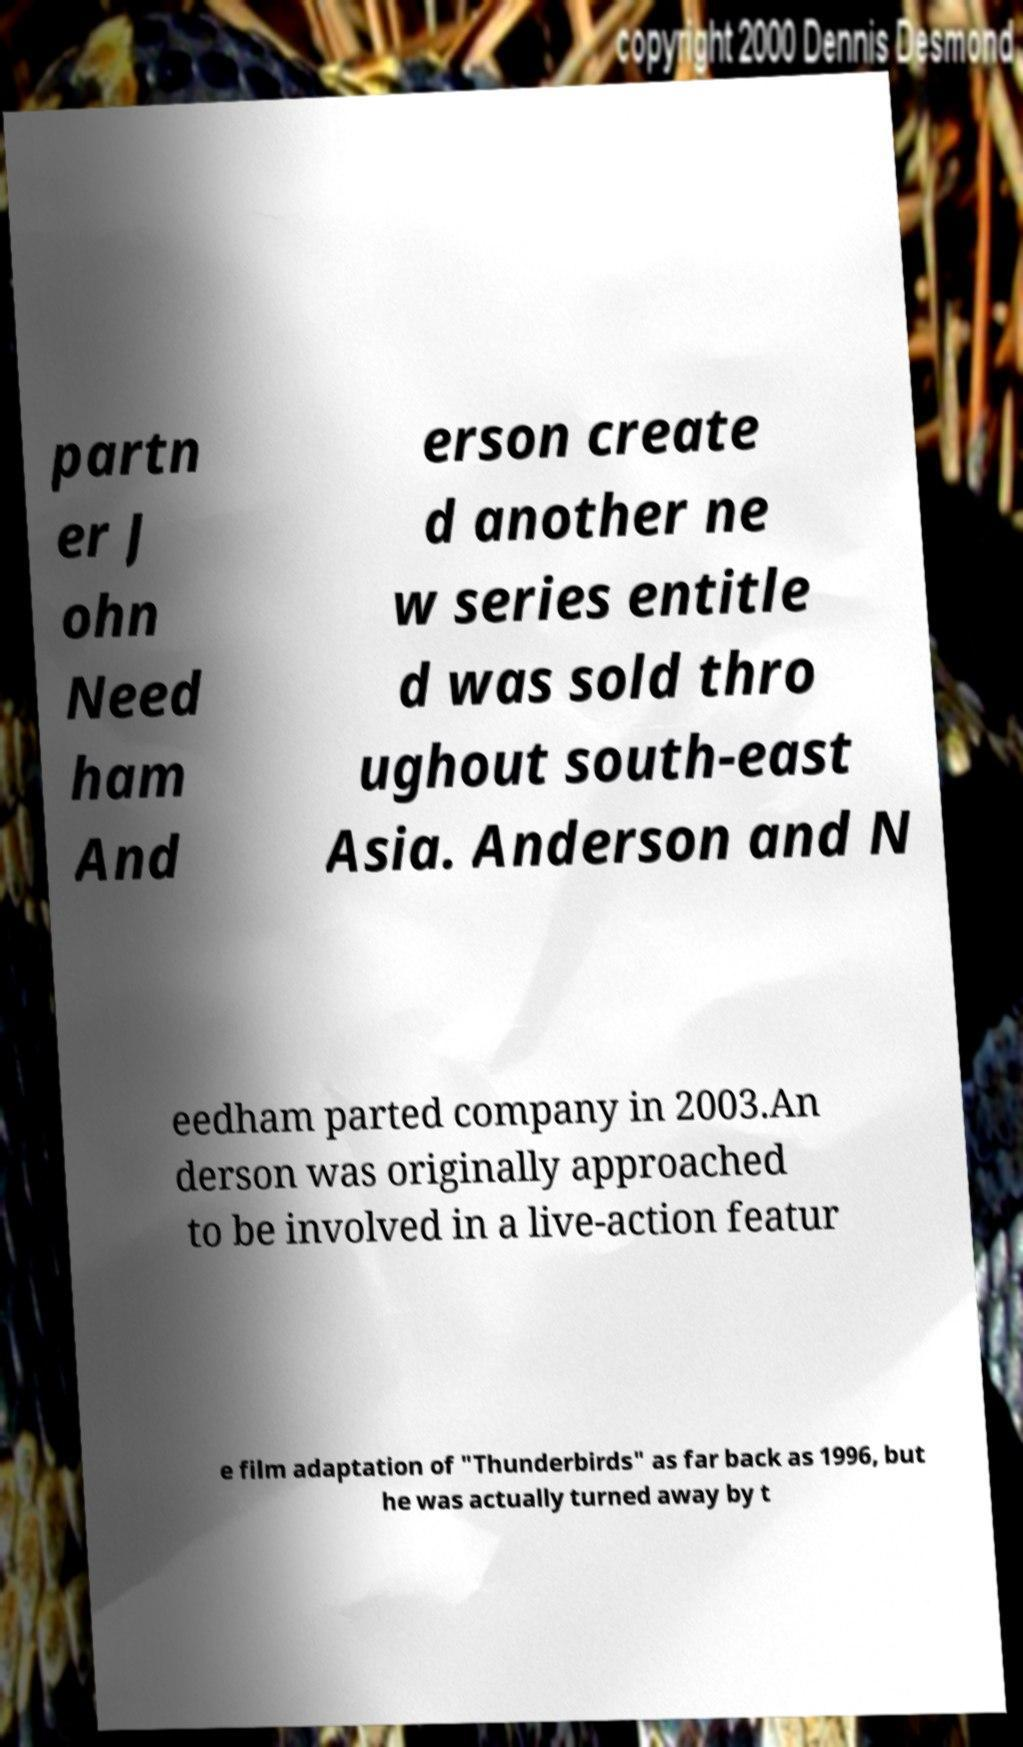For documentation purposes, I need the text within this image transcribed. Could you provide that? partn er J ohn Need ham And erson create d another ne w series entitle d was sold thro ughout south-east Asia. Anderson and N eedham parted company in 2003.An derson was originally approached to be involved in a live-action featur e film adaptation of "Thunderbirds" as far back as 1996, but he was actually turned away by t 